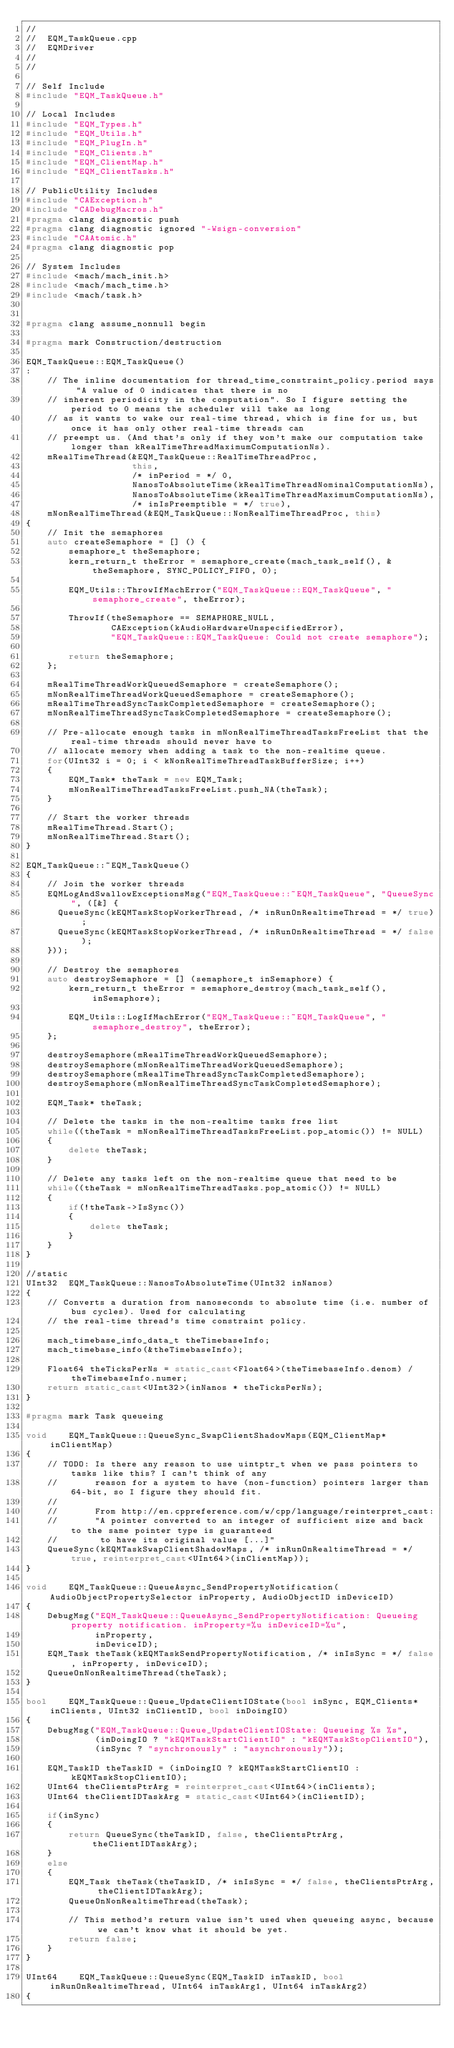<code> <loc_0><loc_0><loc_500><loc_500><_C++_>//
//  EQM_TaskQueue.cpp
//  EQMDriver
//
//

// Self Include
#include "EQM_TaskQueue.h"

// Local Includes
#include "EQM_Types.h"
#include "EQM_Utils.h"
#include "EQM_PlugIn.h"
#include "EQM_Clients.h"
#include "EQM_ClientMap.h"
#include "EQM_ClientTasks.h"

// PublicUtility Includes
#include "CAException.h"
#include "CADebugMacros.h"
#pragma clang diagnostic push
#pragma clang diagnostic ignored "-Wsign-conversion"
#include "CAAtomic.h"
#pragma clang diagnostic pop

// System Includes
#include <mach/mach_init.h>
#include <mach/mach_time.h>
#include <mach/task.h>


#pragma clang assume_nonnull begin

#pragma mark Construction/destruction

EQM_TaskQueue::EQM_TaskQueue()
:
    // The inline documentation for thread_time_constraint_policy.period says "A value of 0 indicates that there is no
    // inherent periodicity in the computation". So I figure setting the period to 0 means the scheduler will take as long
    // as it wants to wake our real-time thread, which is fine for us, but once it has only other real-time threads can
    // preempt us. (And that's only if they won't make our computation take longer than kRealTimeThreadMaximumComputationNs).
    mRealTimeThread(&EQM_TaskQueue::RealTimeThreadProc,
                    this,
                    /* inPeriod = */ 0,
                    NanosToAbsoluteTime(kRealTimeThreadNominalComputationNs),
                    NanosToAbsoluteTime(kRealTimeThreadMaximumComputationNs),
                    /* inIsPreemptible = */ true),
    mNonRealTimeThread(&EQM_TaskQueue::NonRealTimeThreadProc, this)
{
    // Init the semaphores
    auto createSemaphore = [] () {
        semaphore_t theSemaphore;
        kern_return_t theError = semaphore_create(mach_task_self(), &theSemaphore, SYNC_POLICY_FIFO, 0);
        
        EQM_Utils::ThrowIfMachError("EQM_TaskQueue::EQM_TaskQueue", "semaphore_create", theError);
        
        ThrowIf(theSemaphore == SEMAPHORE_NULL,
                CAException(kAudioHardwareUnspecifiedError),
                "EQM_TaskQueue::EQM_TaskQueue: Could not create semaphore");
        
        return theSemaphore;
    };
    
    mRealTimeThreadWorkQueuedSemaphore = createSemaphore();
    mNonRealTimeThreadWorkQueuedSemaphore = createSemaphore();
    mRealTimeThreadSyncTaskCompletedSemaphore = createSemaphore();
    mNonRealTimeThreadSyncTaskCompletedSemaphore = createSemaphore();
    
    // Pre-allocate enough tasks in mNonRealTimeThreadTasksFreeList that the real-time threads should never have to
    // allocate memory when adding a task to the non-realtime queue.
    for(UInt32 i = 0; i < kNonRealTimeThreadTaskBufferSize; i++)
    {
        EQM_Task* theTask = new EQM_Task;
        mNonRealTimeThreadTasksFreeList.push_NA(theTask);
    }
    
    // Start the worker threads
    mRealTimeThread.Start();
    mNonRealTimeThread.Start();
}

EQM_TaskQueue::~EQM_TaskQueue()
{
    // Join the worker threads
    EQMLogAndSwallowExceptionsMsg("EQM_TaskQueue::~EQM_TaskQueue", "QueueSync", ([&] {
      QueueSync(kEQMTaskStopWorkerThread, /* inRunOnRealtimeThread = */ true);
      QueueSync(kEQMTaskStopWorkerThread, /* inRunOnRealtimeThread = */ false);
    }));

    // Destroy the semaphores
    auto destroySemaphore = [] (semaphore_t inSemaphore) {
        kern_return_t theError = semaphore_destroy(mach_task_self(), inSemaphore);
        
        EQM_Utils::LogIfMachError("EQM_TaskQueue::~EQM_TaskQueue", "semaphore_destroy", theError);
    };
    
    destroySemaphore(mRealTimeThreadWorkQueuedSemaphore);
    destroySemaphore(mNonRealTimeThreadWorkQueuedSemaphore);
    destroySemaphore(mRealTimeThreadSyncTaskCompletedSemaphore);
    destroySemaphore(mNonRealTimeThreadSyncTaskCompletedSemaphore);
    
    EQM_Task* theTask;
    
    // Delete the tasks in the non-realtime tasks free list
    while((theTask = mNonRealTimeThreadTasksFreeList.pop_atomic()) != NULL)
    {
        delete theTask;
    }
    
    // Delete any tasks left on the non-realtime queue that need to be
    while((theTask = mNonRealTimeThreadTasks.pop_atomic()) != NULL)
    {
        if(!theTask->IsSync())
        {
            delete theTask;
        }
    }
}

//static
UInt32  EQM_TaskQueue::NanosToAbsoluteTime(UInt32 inNanos)
{
    // Converts a duration from nanoseconds to absolute time (i.e. number of bus cycles). Used for calculating
    // the real-time thread's time constraint policy.
    
    mach_timebase_info_data_t theTimebaseInfo;
    mach_timebase_info(&theTimebaseInfo);
    
    Float64 theTicksPerNs = static_cast<Float64>(theTimebaseInfo.denom) / theTimebaseInfo.numer;
    return static_cast<UInt32>(inNanos * theTicksPerNs);
}

#pragma mark Task queueing

void    EQM_TaskQueue::QueueSync_SwapClientShadowMaps(EQM_ClientMap* inClientMap)
{
    // TODO: Is there any reason to use uintptr_t when we pass pointers to tasks like this? I can't think of any
    //       reason for a system to have (non-function) pointers larger than 64-bit, so I figure they should fit.
    //
    //       From http://en.cppreference.com/w/cpp/language/reinterpret_cast:
    //       "A pointer converted to an integer of sufficient size and back to the same pointer type is guaranteed
    //        to have its original value [...]"
    QueueSync(kEQMTaskSwapClientShadowMaps, /* inRunOnRealtimeThread = */ true, reinterpret_cast<UInt64>(inClientMap));
}

void    EQM_TaskQueue::QueueAsync_SendPropertyNotification(AudioObjectPropertySelector inProperty, AudioObjectID inDeviceID)
{
    DebugMsg("EQM_TaskQueue::QueueAsync_SendPropertyNotification: Queueing property notification. inProperty=%u inDeviceID=%u",
             inProperty,
             inDeviceID);
    EQM_Task theTask(kEQMTaskSendPropertyNotification, /* inIsSync = */ false, inProperty, inDeviceID);
    QueueOnNonRealtimeThread(theTask);
}

bool    EQM_TaskQueue::Queue_UpdateClientIOState(bool inSync, EQM_Clients* inClients, UInt32 inClientID, bool inDoingIO)
{
    DebugMsg("EQM_TaskQueue::Queue_UpdateClientIOState: Queueing %s %s",
             (inDoingIO ? "kEQMTaskStartClientIO" : "kEQMTaskStopClientIO"),
             (inSync ? "synchronously" : "asynchronously"));
    
    EQM_TaskID theTaskID = (inDoingIO ? kEQMTaskStartClientIO : kEQMTaskStopClientIO);
    UInt64 theClientsPtrArg = reinterpret_cast<UInt64>(inClients);
    UInt64 theClientIDTaskArg = static_cast<UInt64>(inClientID);
    
    if(inSync)
    {
        return QueueSync(theTaskID, false, theClientsPtrArg, theClientIDTaskArg);
    }
    else
    {
        EQM_Task theTask(theTaskID, /* inIsSync = */ false, theClientsPtrArg, theClientIDTaskArg);
        QueueOnNonRealtimeThread(theTask);
        
        // This method's return value isn't used when queueing async, because we can't know what it should be yet.
        return false;
    }
}

UInt64    EQM_TaskQueue::QueueSync(EQM_TaskID inTaskID, bool inRunOnRealtimeThread, UInt64 inTaskArg1, UInt64 inTaskArg2)
{</code> 